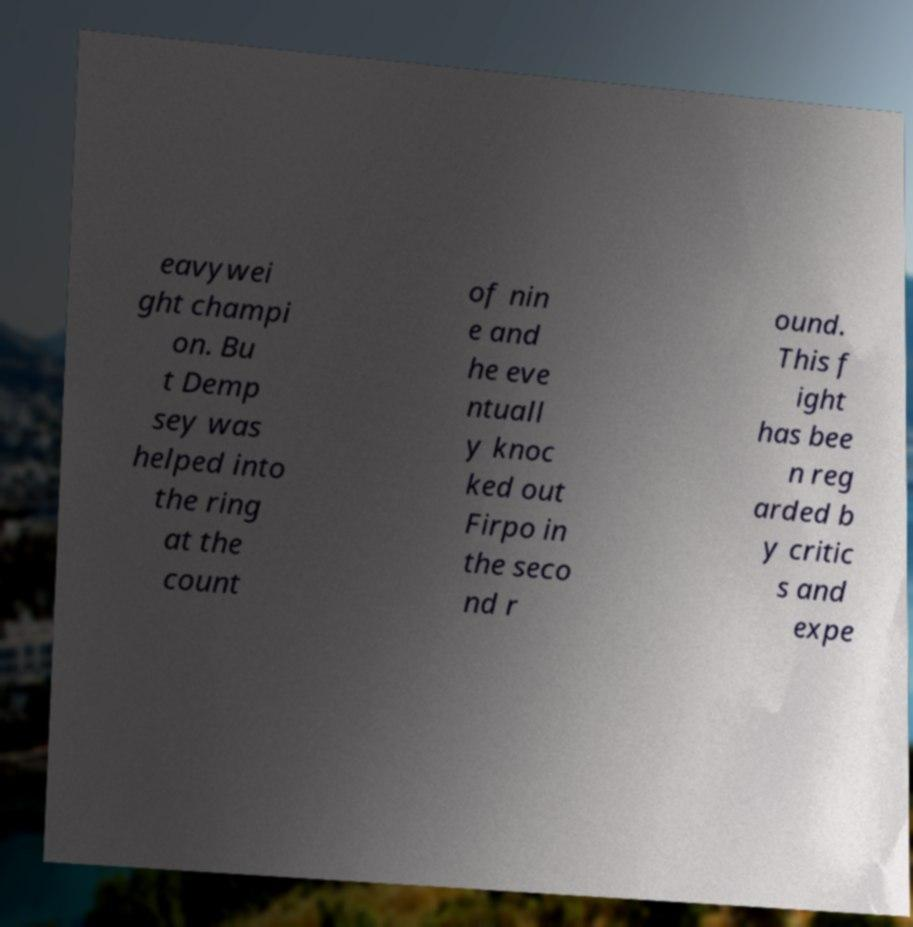I need the written content from this picture converted into text. Can you do that? eavywei ght champi on. Bu t Demp sey was helped into the ring at the count of nin e and he eve ntuall y knoc ked out Firpo in the seco nd r ound. This f ight has bee n reg arded b y critic s and expe 